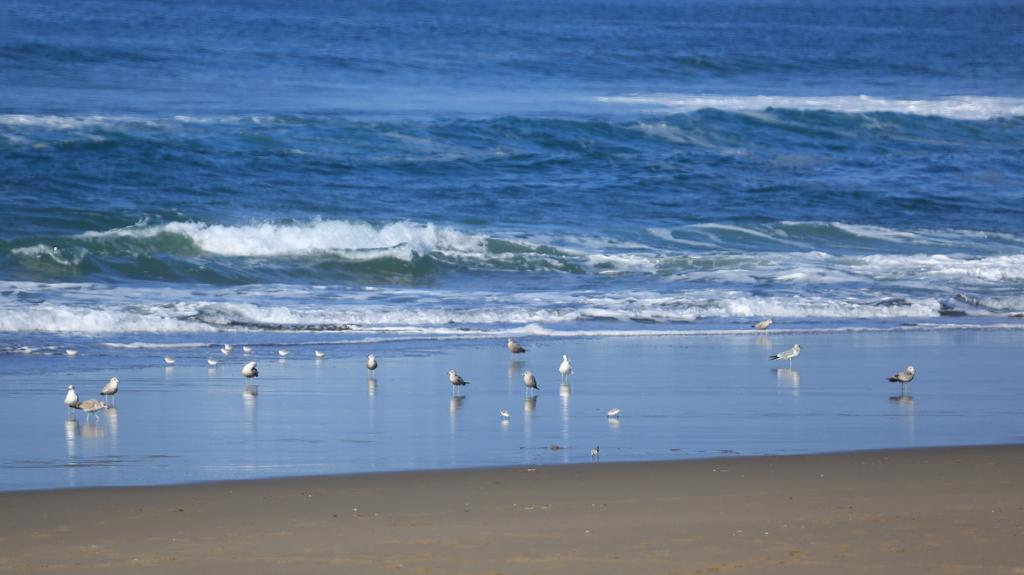Please provide a concise description of this image. This image is taken outdoors. At the bottom of the image there is a ground. In the background there is a sea with waves. In the middle of the image there are a few birds on the ground. 